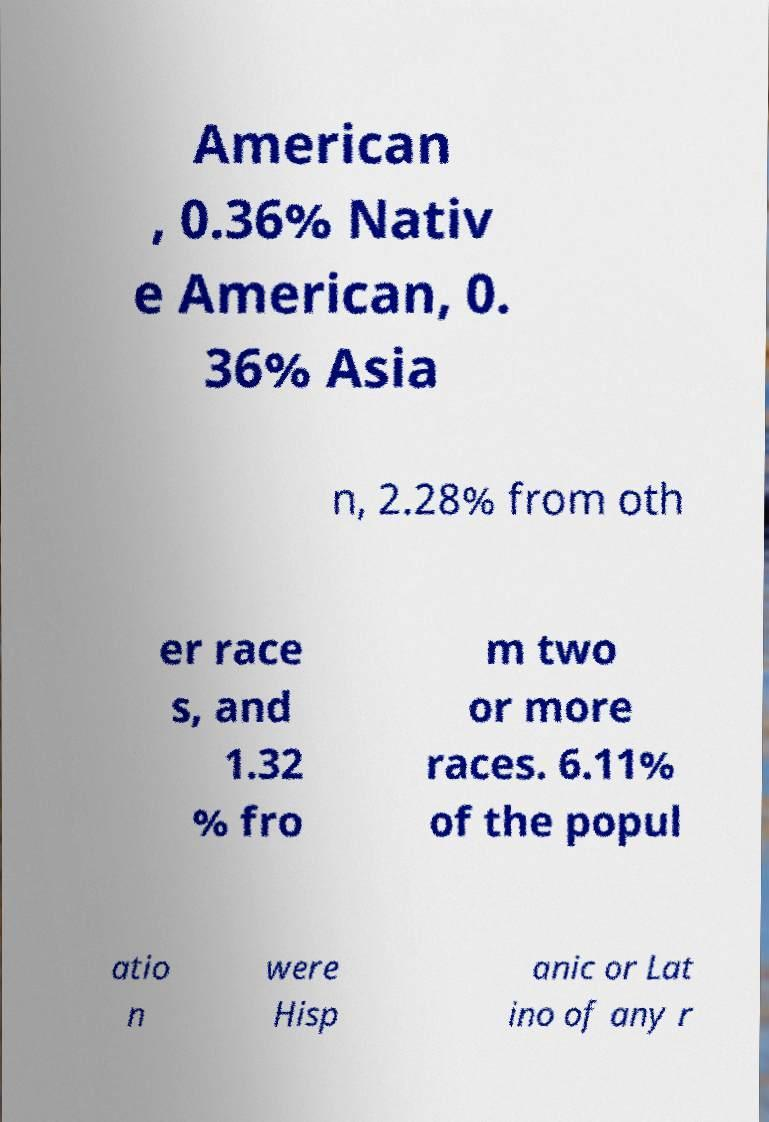Can you accurately transcribe the text from the provided image for me? American , 0.36% Nativ e American, 0. 36% Asia n, 2.28% from oth er race s, and 1.32 % fro m two or more races. 6.11% of the popul atio n were Hisp anic or Lat ino of any r 